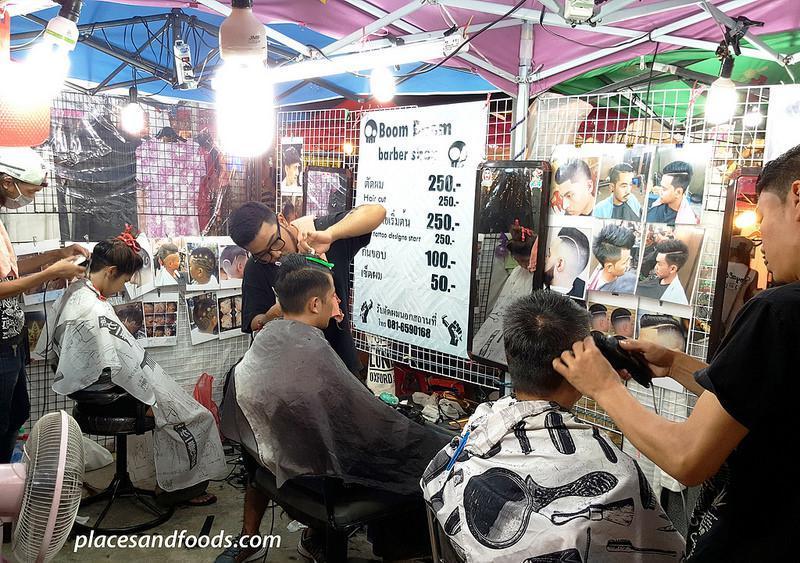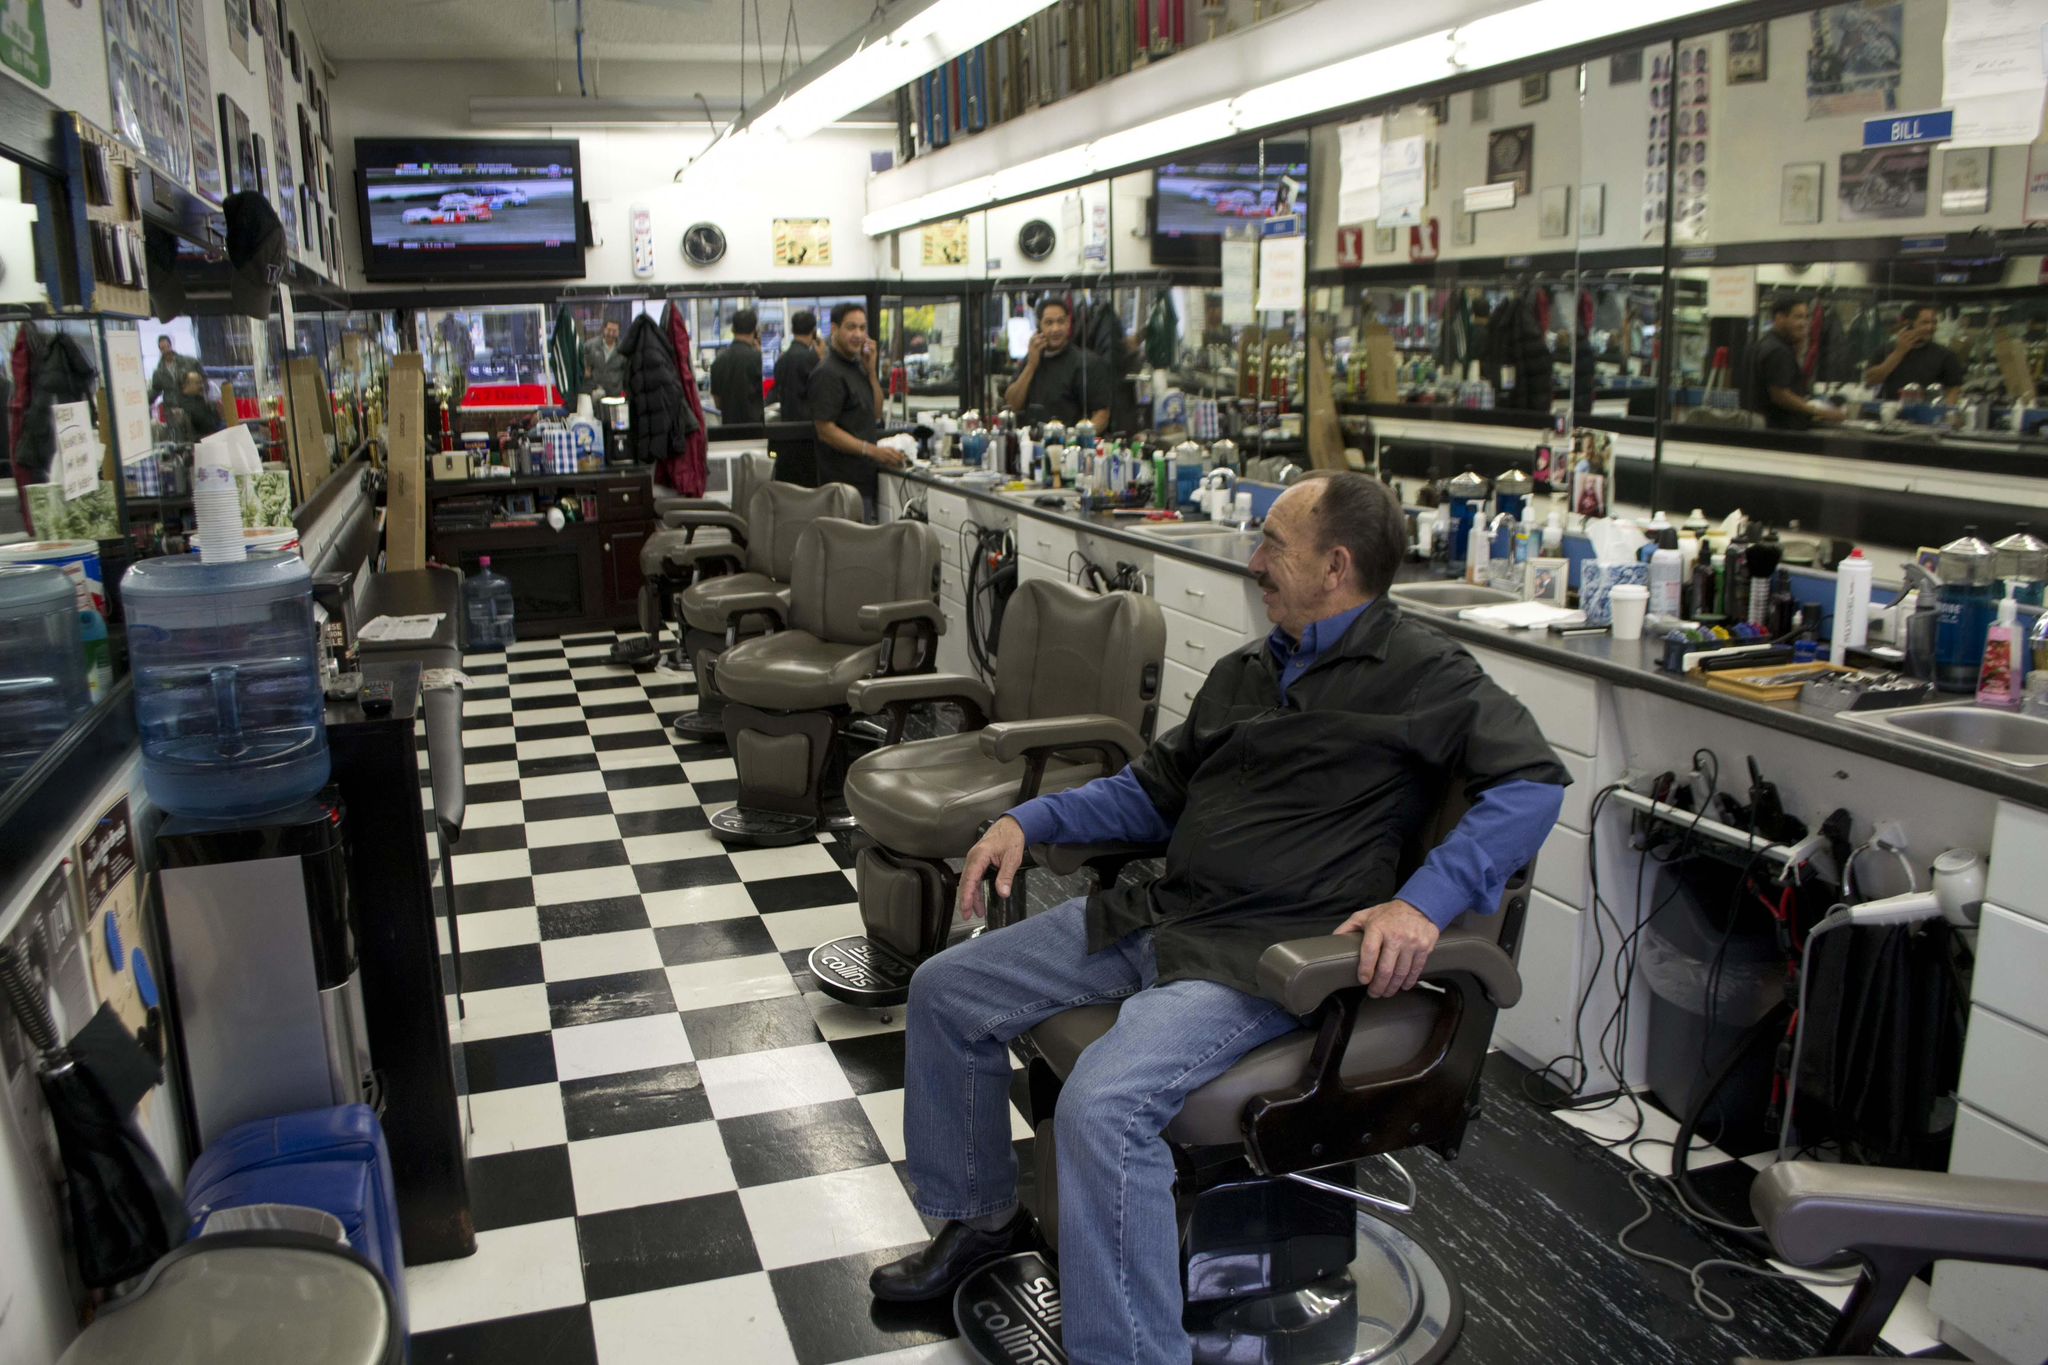The first image is the image on the left, the second image is the image on the right. Examine the images to the left and right. Is the description "In the left image the person furthest to the left is cutting another persons hair that is seated in a barbers chair." accurate? Answer yes or no. Yes. The first image is the image on the left, the second image is the image on the right. For the images shown, is this caption "There is a TV mounted high on the wall  in a barbershop with at least three barber chairs available to sit in." true? Answer yes or no. Yes. 